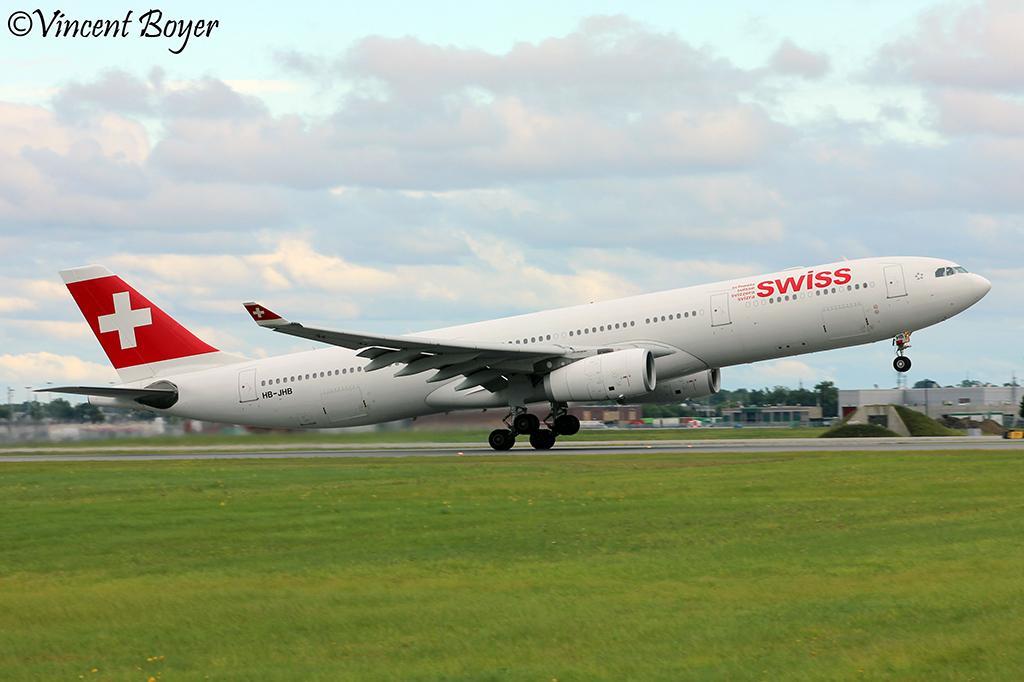How would you summarize this image in a sentence or two? In this picture we can observe an airplane on the runway. There is some grass on the ground. In the background there are buildings and trees. We can observe a sky with clouds. On the left side there are brown color words. 